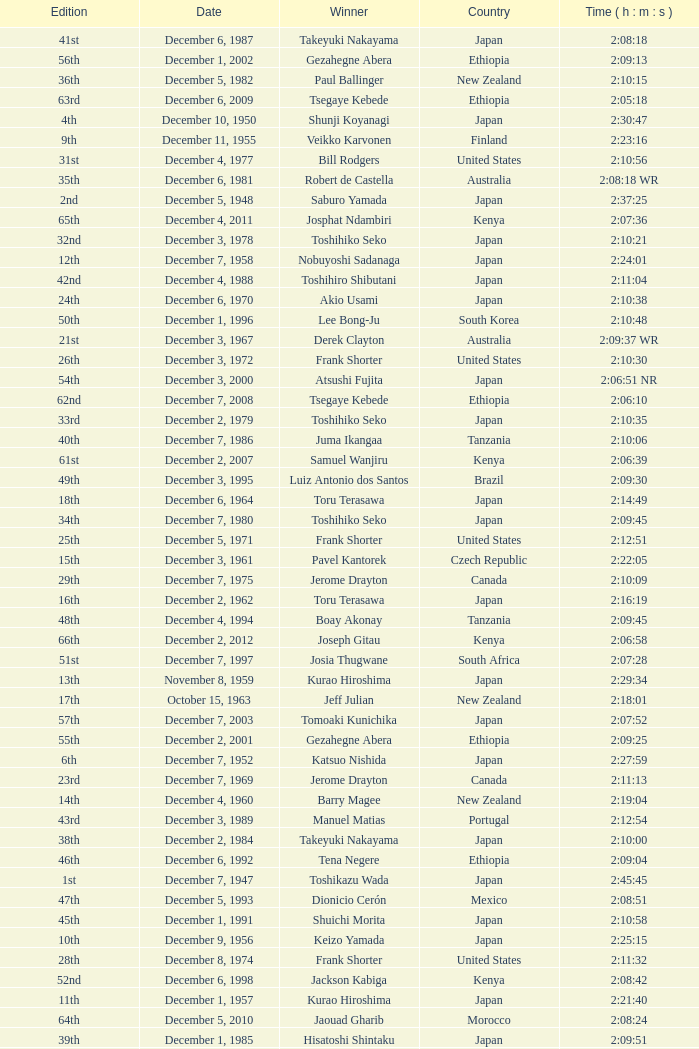On what date was the 48th Edition raced? December 4, 1994. 